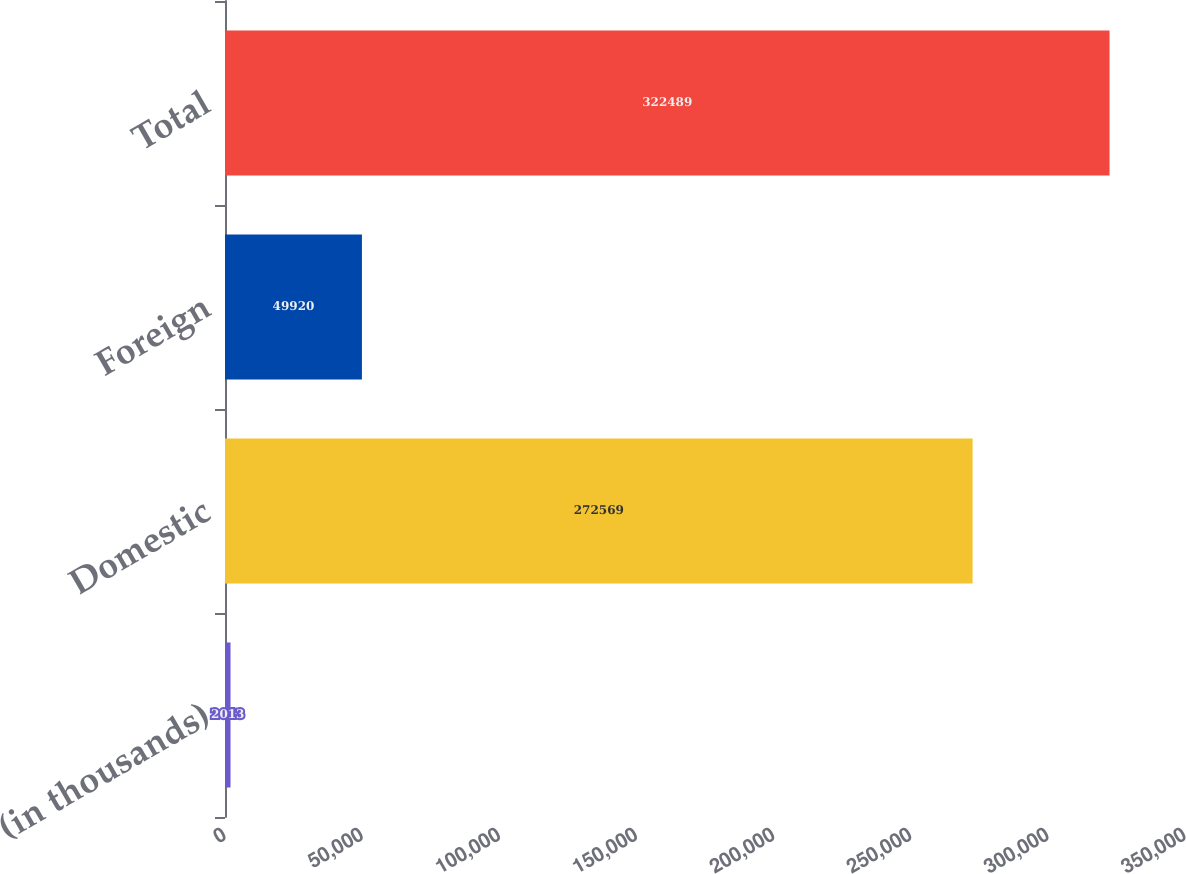Convert chart to OTSL. <chart><loc_0><loc_0><loc_500><loc_500><bar_chart><fcel>(in thousands)<fcel>Domestic<fcel>Foreign<fcel>Total<nl><fcel>2013<fcel>272569<fcel>49920<fcel>322489<nl></chart> 